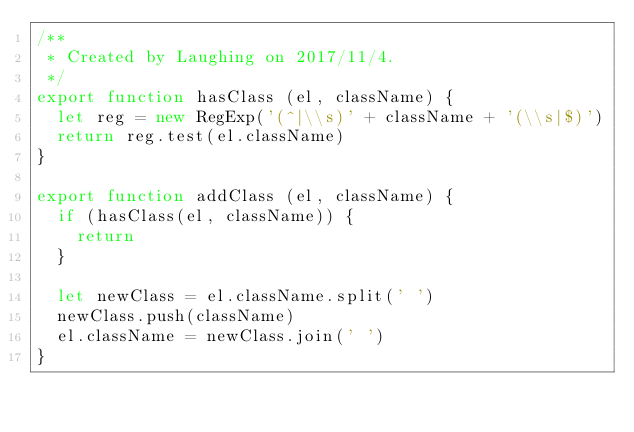Convert code to text. <code><loc_0><loc_0><loc_500><loc_500><_JavaScript_>/**
 * Created by Laughing on 2017/11/4.
 */
export function hasClass (el, className) {
  let reg = new RegExp('(^|\\s)' + className + '(\\s|$)')
  return reg.test(el.className)
}

export function addClass (el, className) {
  if (hasClass(el, className)) {
    return
  }

  let newClass = el.className.split(' ')
  newClass.push(className)
  el.className = newClass.join(' ')
}
</code> 